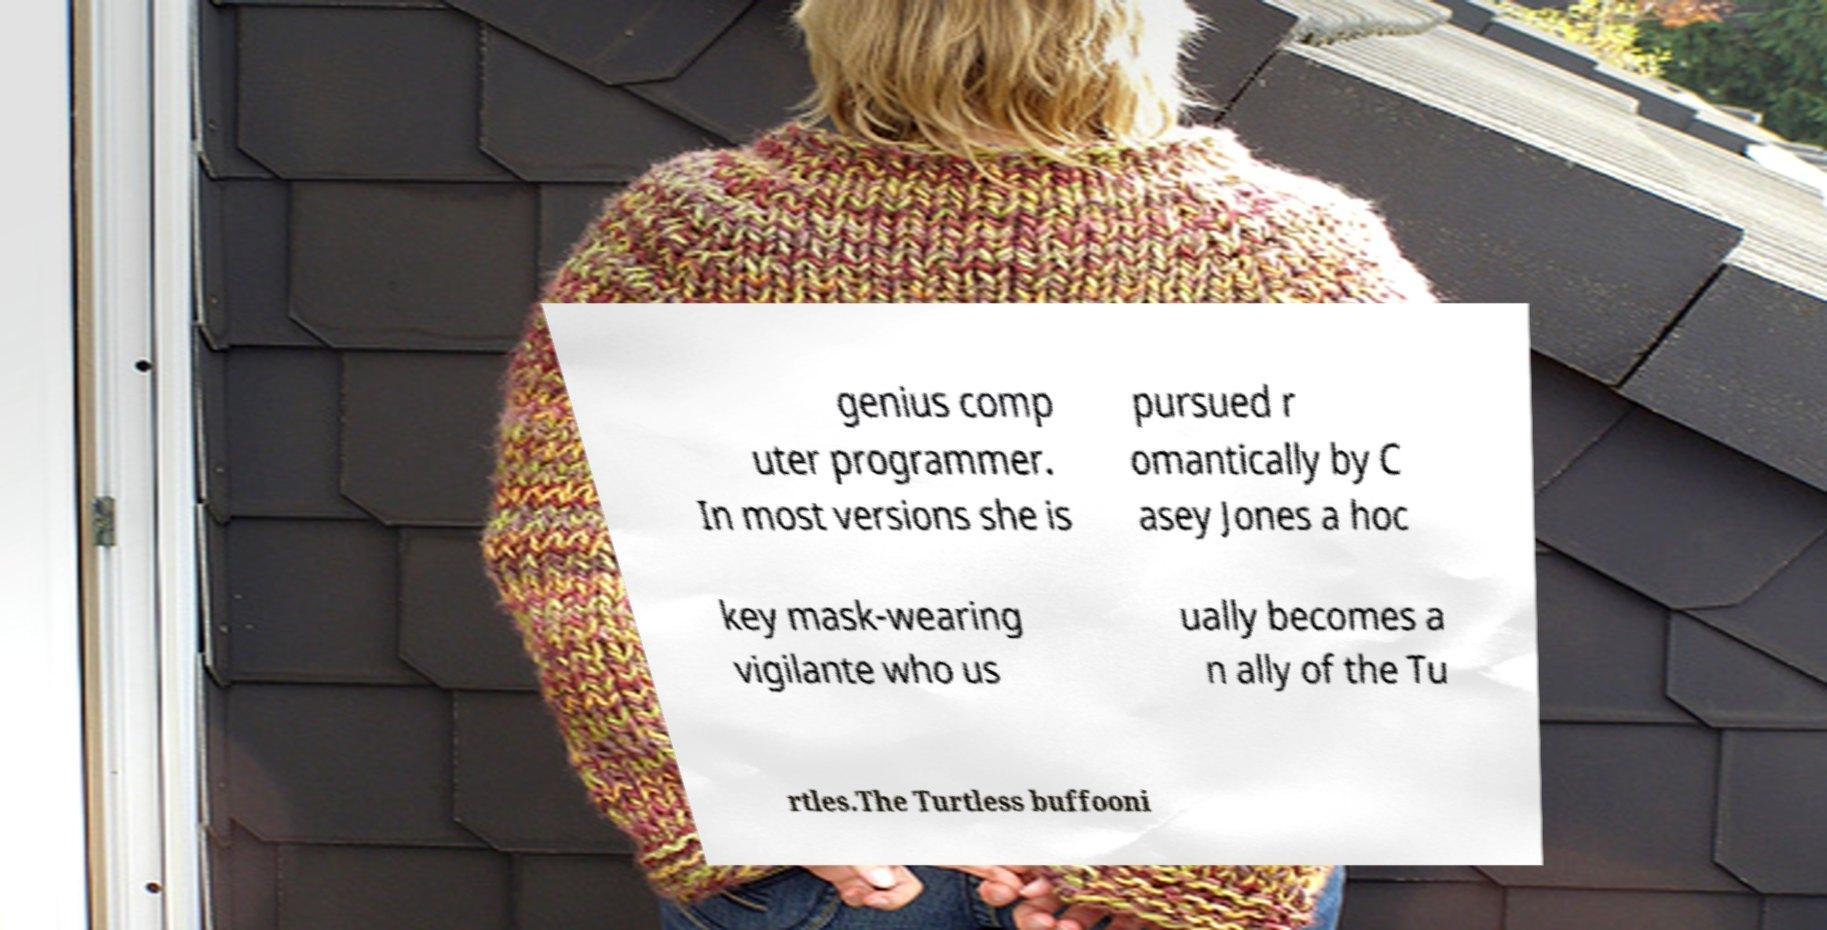Please read and relay the text visible in this image. What does it say? genius comp uter programmer. In most versions she is pursued r omantically by C asey Jones a hoc key mask-wearing vigilante who us ually becomes a n ally of the Tu rtles.The Turtless buffooni 